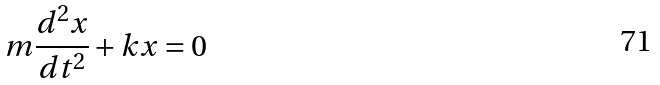Convert formula to latex. <formula><loc_0><loc_0><loc_500><loc_500>m \frac { d ^ { 2 } x } { d t ^ { 2 } } + k x = 0</formula> 